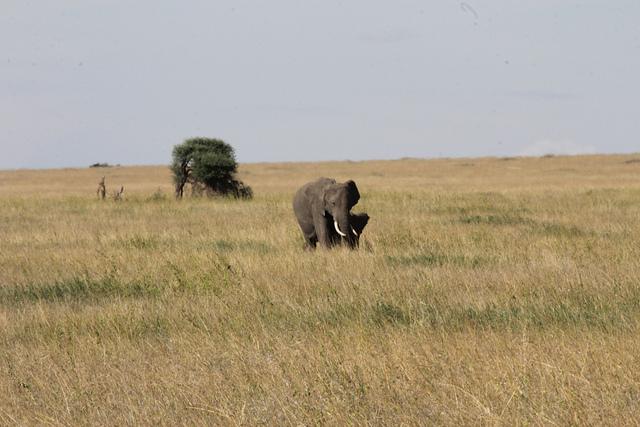Can you see a tree?
Concise answer only. Yes. Does the elephant have tusks?
Answer briefly. Yes. Does this elephant have a baby with it?
Short answer required. Yes. What type of day is this?
Concise answer only. Overcast. What color is this animal?
Quick response, please. Gray. How many animals?
Answer briefly. 1. 